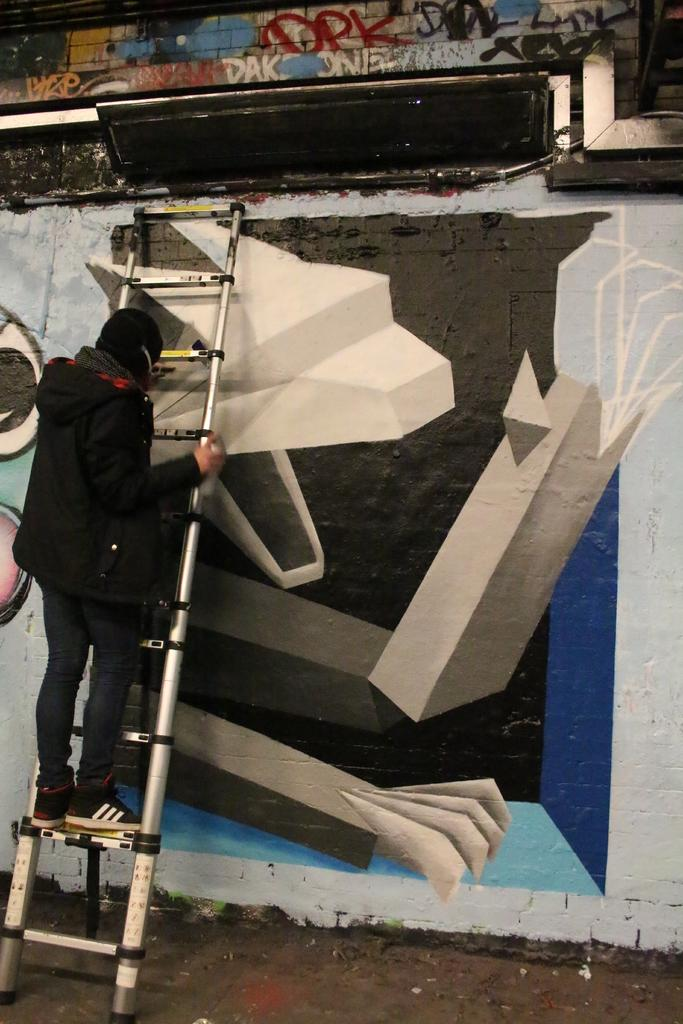What is the person in the image doing? The person is visible on the ladder. How is the ladder positioned in the image? The ladder is attached to the wall. What can be seen on the wall in the image? There is a design on the wall. How does the person say good-bye to the wall in the image? There is no indication in the image that the person is saying good-bye to the wall, as they are simply on the ladder. 